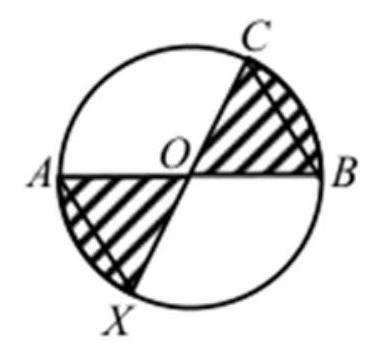Can you explain how the equal lengths of OB and BC affect the shaded area? Certainly! Since OB equals BC, triangle OBC is an isosceles triangle. If OB and BC are also radii of the circle, then the triangle is an isosceles right triangle with both angles at O and B being 45 degrees. This triangle's area would be half the area of a square with side OB or BC. Understanding this allows us to deduce the structure of the rest of the circle. The shaded areas are two quarter-circles minus this isosceles right triangle. Therefore, the shaded area's size solely depends on the areas of those circular sectors and the triangle OBC. 